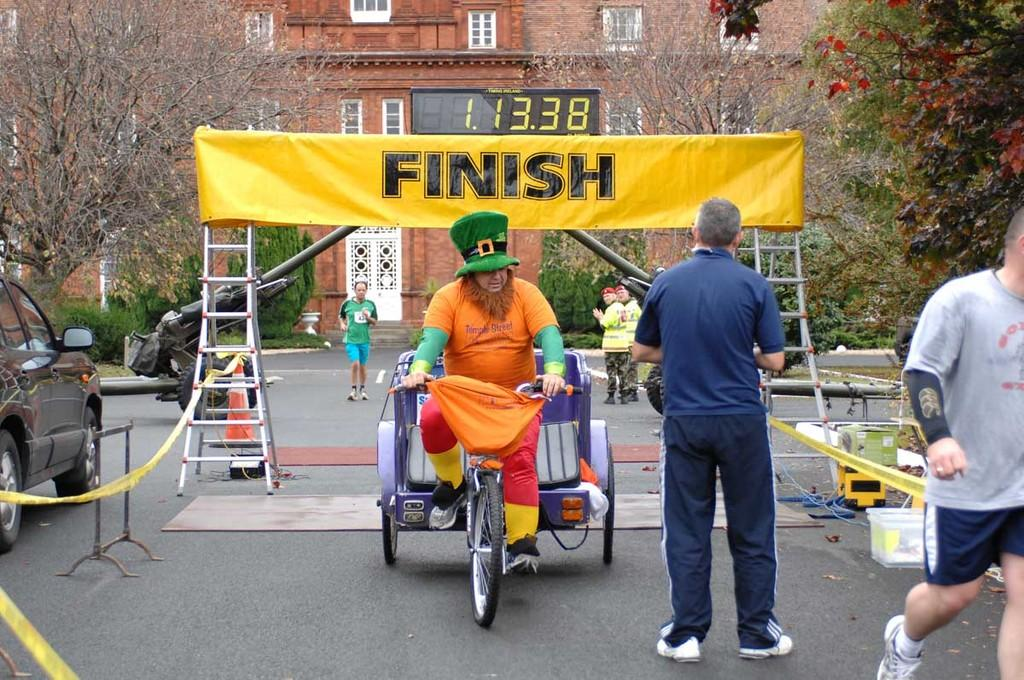How many people can be seen in the image? There are people in the image, but the exact number cannot be determined from the provided facts. What type of vehicle is present in the image? There is a vehicle in the image, but the specific type cannot be determined from the provided facts. What is written on the banner in the image? The content of the banner cannot be determined from the provided facts. What color is the car in the image? There is a black color car in the image. What type of vegetation is present in the image? There are trees in the image. What type of structure is present in the image? There is a building in the image. What type of clouds can be seen in the image? There is no mention of clouds in the provided facts, so it cannot be determined if any are present in the image. What is the zinc content of the car in the image? The zinc content of the car cannot be determined from the provided facts, as they do not mention any chemical composition or material properties of the car. 